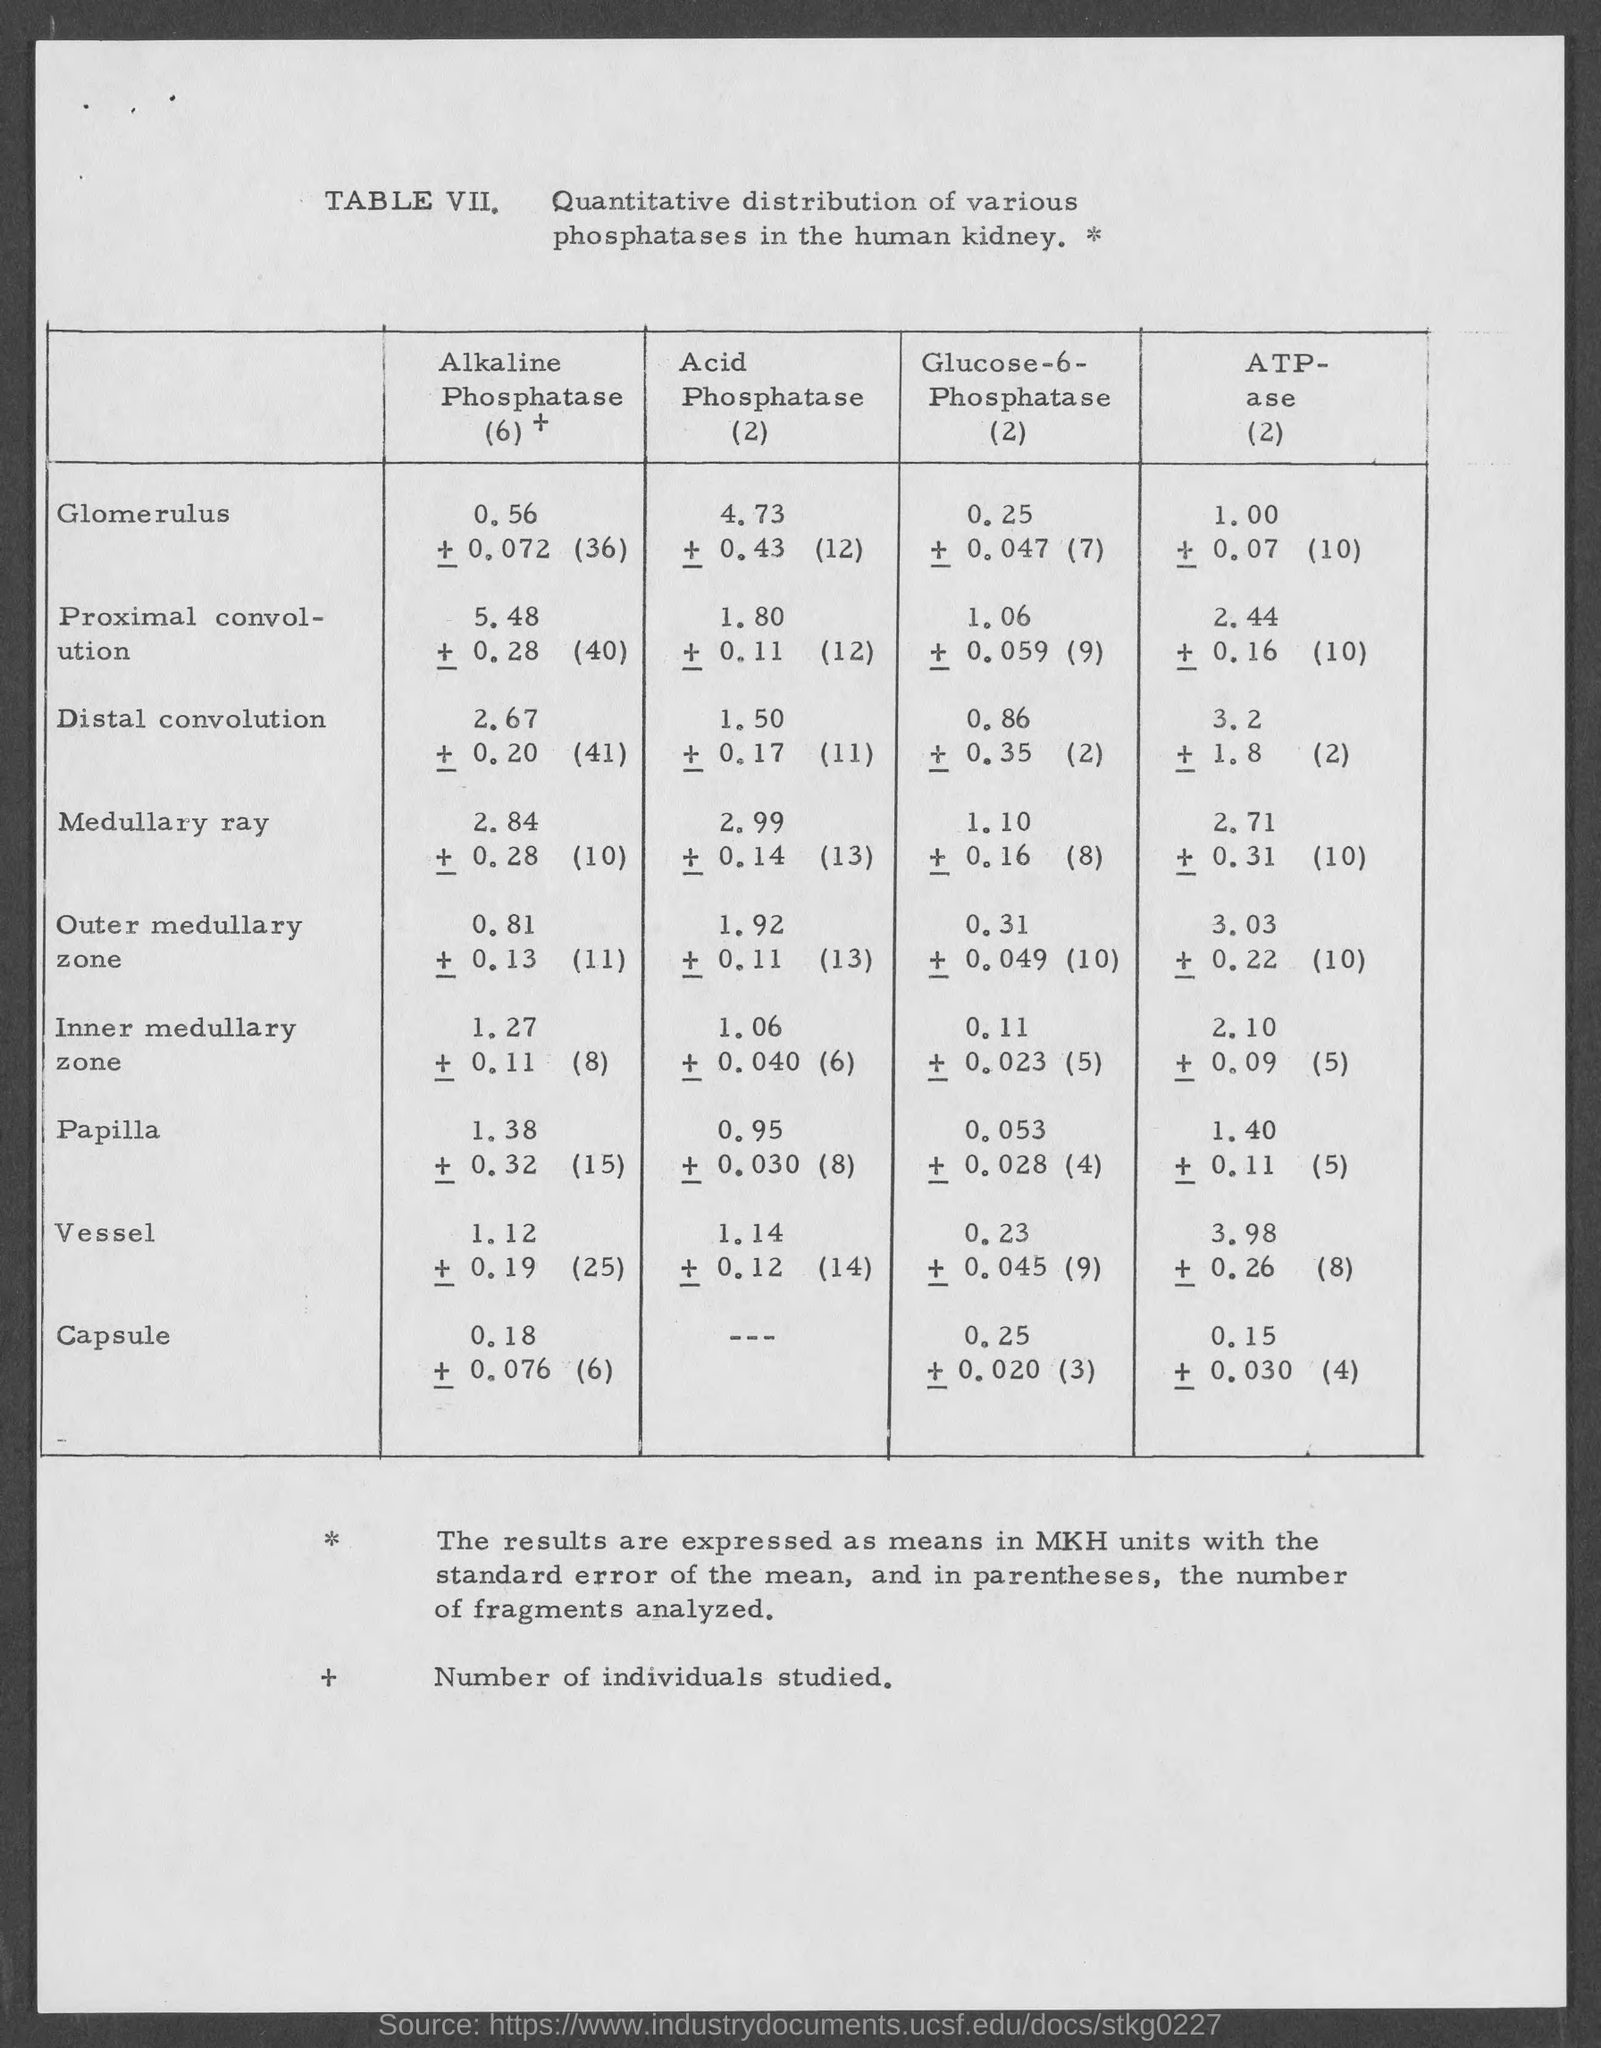What does TABLE VIII describe?
Your answer should be very brief. Quantitative distribution of various phosphatases in the human kidney. 